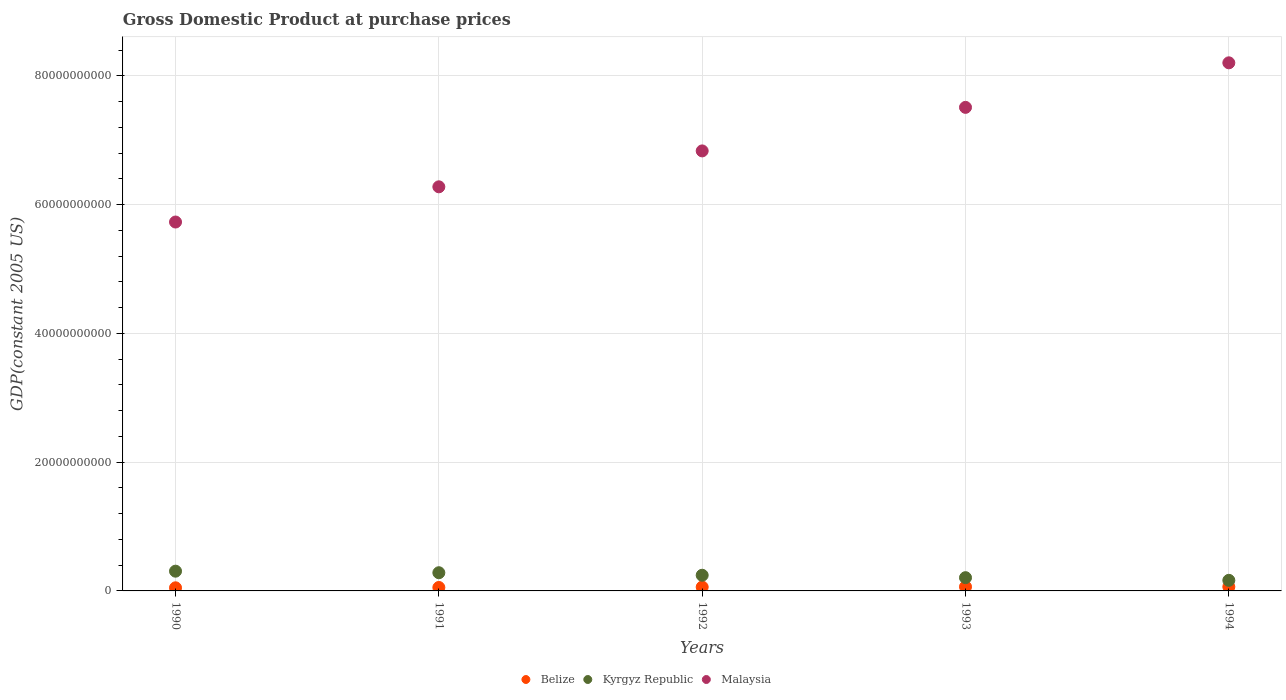What is the GDP at purchase prices in Belize in 1992?
Give a very brief answer. 5.99e+08. Across all years, what is the maximum GDP at purchase prices in Malaysia?
Your answer should be very brief. 8.20e+1. Across all years, what is the minimum GDP at purchase prices in Kyrgyz Republic?
Your response must be concise. 1.64e+09. In which year was the GDP at purchase prices in Kyrgyz Republic maximum?
Give a very brief answer. 1990. In which year was the GDP at purchase prices in Kyrgyz Republic minimum?
Your answer should be very brief. 1994. What is the total GDP at purchase prices in Malaysia in the graph?
Give a very brief answer. 3.46e+11. What is the difference between the GDP at purchase prices in Kyrgyz Republic in 1990 and that in 1991?
Offer a very short reply. 2.41e+08. What is the difference between the GDP at purchase prices in Belize in 1993 and the GDP at purchase prices in Malaysia in 1991?
Provide a succinct answer. -6.21e+1. What is the average GDP at purchase prices in Kyrgyz Republic per year?
Provide a succinct answer. 2.41e+09. In the year 1993, what is the difference between the GDP at purchase prices in Belize and GDP at purchase prices in Kyrgyz Republic?
Offer a terse response. -1.42e+09. In how many years, is the GDP at purchase prices in Belize greater than 24000000000 US$?
Offer a terse response. 0. What is the ratio of the GDP at purchase prices in Kyrgyz Republic in 1990 to that in 1992?
Provide a succinct answer. 1.26. Is the GDP at purchase prices in Kyrgyz Republic in 1992 less than that in 1993?
Give a very brief answer. No. Is the difference between the GDP at purchase prices in Belize in 1990 and 1994 greater than the difference between the GDP at purchase prices in Kyrgyz Republic in 1990 and 1994?
Provide a succinct answer. No. What is the difference between the highest and the second highest GDP at purchase prices in Kyrgyz Republic?
Keep it short and to the point. 2.41e+08. What is the difference between the highest and the lowest GDP at purchase prices in Kyrgyz Republic?
Give a very brief answer. 1.42e+09. Is the sum of the GDP at purchase prices in Malaysia in 1990 and 1991 greater than the maximum GDP at purchase prices in Belize across all years?
Your answer should be very brief. Yes. Is it the case that in every year, the sum of the GDP at purchase prices in Belize and GDP at purchase prices in Kyrgyz Republic  is greater than the GDP at purchase prices in Malaysia?
Offer a terse response. No. Does the GDP at purchase prices in Kyrgyz Republic monotonically increase over the years?
Your answer should be compact. No. What is the difference between two consecutive major ticks on the Y-axis?
Ensure brevity in your answer.  2.00e+1. Are the values on the major ticks of Y-axis written in scientific E-notation?
Ensure brevity in your answer.  No. Does the graph contain any zero values?
Ensure brevity in your answer.  No. Does the graph contain grids?
Make the answer very short. Yes. Where does the legend appear in the graph?
Your answer should be very brief. Bottom center. How are the legend labels stacked?
Your response must be concise. Horizontal. What is the title of the graph?
Give a very brief answer. Gross Domestic Product at purchase prices. Does "Montenegro" appear as one of the legend labels in the graph?
Provide a succinct answer. No. What is the label or title of the Y-axis?
Keep it short and to the point. GDP(constant 2005 US). What is the GDP(constant 2005 US) in Belize in 1990?
Your answer should be very brief. 4.84e+08. What is the GDP(constant 2005 US) in Kyrgyz Republic in 1990?
Your answer should be compact. 3.07e+09. What is the GDP(constant 2005 US) of Malaysia in 1990?
Make the answer very short. 5.73e+1. What is the GDP(constant 2005 US) of Belize in 1991?
Ensure brevity in your answer.  5.35e+08. What is the GDP(constant 2005 US) in Kyrgyz Republic in 1991?
Make the answer very short. 2.83e+09. What is the GDP(constant 2005 US) of Malaysia in 1991?
Provide a short and direct response. 6.28e+1. What is the GDP(constant 2005 US) of Belize in 1992?
Offer a very short reply. 5.99e+08. What is the GDP(constant 2005 US) of Kyrgyz Republic in 1992?
Provide a short and direct response. 2.43e+09. What is the GDP(constant 2005 US) of Malaysia in 1992?
Keep it short and to the point. 6.84e+1. What is the GDP(constant 2005 US) of Belize in 1993?
Make the answer very short. 6.37e+08. What is the GDP(constant 2005 US) of Kyrgyz Republic in 1993?
Your answer should be compact. 2.06e+09. What is the GDP(constant 2005 US) in Malaysia in 1993?
Make the answer very short. 7.51e+1. What is the GDP(constant 2005 US) of Belize in 1994?
Provide a succinct answer. 6.38e+08. What is the GDP(constant 2005 US) of Kyrgyz Republic in 1994?
Make the answer very short. 1.64e+09. What is the GDP(constant 2005 US) in Malaysia in 1994?
Ensure brevity in your answer.  8.20e+1. Across all years, what is the maximum GDP(constant 2005 US) in Belize?
Your response must be concise. 6.38e+08. Across all years, what is the maximum GDP(constant 2005 US) in Kyrgyz Republic?
Provide a succinct answer. 3.07e+09. Across all years, what is the maximum GDP(constant 2005 US) of Malaysia?
Your response must be concise. 8.20e+1. Across all years, what is the minimum GDP(constant 2005 US) of Belize?
Offer a terse response. 4.84e+08. Across all years, what is the minimum GDP(constant 2005 US) of Kyrgyz Republic?
Your answer should be very brief. 1.64e+09. Across all years, what is the minimum GDP(constant 2005 US) of Malaysia?
Make the answer very short. 5.73e+1. What is the total GDP(constant 2005 US) of Belize in the graph?
Offer a terse response. 2.89e+09. What is the total GDP(constant 2005 US) of Kyrgyz Republic in the graph?
Keep it short and to the point. 1.20e+1. What is the total GDP(constant 2005 US) of Malaysia in the graph?
Give a very brief answer. 3.46e+11. What is the difference between the GDP(constant 2005 US) in Belize in 1990 and that in 1991?
Give a very brief answer. -5.08e+07. What is the difference between the GDP(constant 2005 US) of Kyrgyz Republic in 1990 and that in 1991?
Your response must be concise. 2.41e+08. What is the difference between the GDP(constant 2005 US) in Malaysia in 1990 and that in 1991?
Your answer should be very brief. -5.47e+09. What is the difference between the GDP(constant 2005 US) of Belize in 1990 and that in 1992?
Offer a very short reply. -1.15e+08. What is the difference between the GDP(constant 2005 US) of Kyrgyz Republic in 1990 and that in 1992?
Your answer should be very brief. 6.33e+08. What is the difference between the GDP(constant 2005 US) in Malaysia in 1990 and that in 1992?
Keep it short and to the point. -1.10e+1. What is the difference between the GDP(constant 2005 US) in Belize in 1990 and that in 1993?
Keep it short and to the point. -1.53e+08. What is the difference between the GDP(constant 2005 US) of Kyrgyz Republic in 1990 and that in 1993?
Your response must be concise. 1.01e+09. What is the difference between the GDP(constant 2005 US) of Malaysia in 1990 and that in 1993?
Keep it short and to the point. -1.78e+1. What is the difference between the GDP(constant 2005 US) in Belize in 1990 and that in 1994?
Your answer should be compact. -1.54e+08. What is the difference between the GDP(constant 2005 US) of Kyrgyz Republic in 1990 and that in 1994?
Offer a very short reply. 1.42e+09. What is the difference between the GDP(constant 2005 US) of Malaysia in 1990 and that in 1994?
Give a very brief answer. -2.47e+1. What is the difference between the GDP(constant 2005 US) in Belize in 1991 and that in 1992?
Your answer should be compact. -6.44e+07. What is the difference between the GDP(constant 2005 US) of Kyrgyz Republic in 1991 and that in 1992?
Provide a short and direct response. 3.93e+08. What is the difference between the GDP(constant 2005 US) in Malaysia in 1991 and that in 1992?
Provide a succinct answer. -5.58e+09. What is the difference between the GDP(constant 2005 US) in Belize in 1991 and that in 1993?
Offer a terse response. -1.02e+08. What is the difference between the GDP(constant 2005 US) in Kyrgyz Republic in 1991 and that in 1993?
Your response must be concise. 7.69e+08. What is the difference between the GDP(constant 2005 US) of Malaysia in 1991 and that in 1993?
Offer a very short reply. -1.23e+1. What is the difference between the GDP(constant 2005 US) of Belize in 1991 and that in 1994?
Ensure brevity in your answer.  -1.03e+08. What is the difference between the GDP(constant 2005 US) of Kyrgyz Republic in 1991 and that in 1994?
Offer a very short reply. 1.18e+09. What is the difference between the GDP(constant 2005 US) of Malaysia in 1991 and that in 1994?
Your response must be concise. -1.93e+1. What is the difference between the GDP(constant 2005 US) of Belize in 1992 and that in 1993?
Your response must be concise. -3.76e+07. What is the difference between the GDP(constant 2005 US) in Kyrgyz Republic in 1992 and that in 1993?
Provide a succinct answer. 3.76e+08. What is the difference between the GDP(constant 2005 US) in Malaysia in 1992 and that in 1993?
Offer a very short reply. -6.76e+09. What is the difference between the GDP(constant 2005 US) in Belize in 1992 and that in 1994?
Ensure brevity in your answer.  -3.86e+07. What is the difference between the GDP(constant 2005 US) in Kyrgyz Republic in 1992 and that in 1994?
Provide a short and direct response. 7.90e+08. What is the difference between the GDP(constant 2005 US) in Malaysia in 1992 and that in 1994?
Ensure brevity in your answer.  -1.37e+1. What is the difference between the GDP(constant 2005 US) in Belize in 1993 and that in 1994?
Your answer should be compact. -1.01e+06. What is the difference between the GDP(constant 2005 US) of Kyrgyz Republic in 1993 and that in 1994?
Make the answer very short. 4.13e+08. What is the difference between the GDP(constant 2005 US) in Malaysia in 1993 and that in 1994?
Make the answer very short. -6.92e+09. What is the difference between the GDP(constant 2005 US) of Belize in 1990 and the GDP(constant 2005 US) of Kyrgyz Republic in 1991?
Offer a terse response. -2.34e+09. What is the difference between the GDP(constant 2005 US) in Belize in 1990 and the GDP(constant 2005 US) in Malaysia in 1991?
Provide a succinct answer. -6.23e+1. What is the difference between the GDP(constant 2005 US) of Kyrgyz Republic in 1990 and the GDP(constant 2005 US) of Malaysia in 1991?
Provide a short and direct response. -5.97e+1. What is the difference between the GDP(constant 2005 US) of Belize in 1990 and the GDP(constant 2005 US) of Kyrgyz Republic in 1992?
Your answer should be compact. -1.95e+09. What is the difference between the GDP(constant 2005 US) in Belize in 1990 and the GDP(constant 2005 US) in Malaysia in 1992?
Provide a succinct answer. -6.79e+1. What is the difference between the GDP(constant 2005 US) in Kyrgyz Republic in 1990 and the GDP(constant 2005 US) in Malaysia in 1992?
Your response must be concise. -6.53e+1. What is the difference between the GDP(constant 2005 US) of Belize in 1990 and the GDP(constant 2005 US) of Kyrgyz Republic in 1993?
Offer a very short reply. -1.57e+09. What is the difference between the GDP(constant 2005 US) of Belize in 1990 and the GDP(constant 2005 US) of Malaysia in 1993?
Keep it short and to the point. -7.46e+1. What is the difference between the GDP(constant 2005 US) of Kyrgyz Republic in 1990 and the GDP(constant 2005 US) of Malaysia in 1993?
Offer a very short reply. -7.21e+1. What is the difference between the GDP(constant 2005 US) in Belize in 1990 and the GDP(constant 2005 US) in Kyrgyz Republic in 1994?
Offer a terse response. -1.16e+09. What is the difference between the GDP(constant 2005 US) in Belize in 1990 and the GDP(constant 2005 US) in Malaysia in 1994?
Your answer should be compact. -8.16e+1. What is the difference between the GDP(constant 2005 US) of Kyrgyz Republic in 1990 and the GDP(constant 2005 US) of Malaysia in 1994?
Offer a very short reply. -7.90e+1. What is the difference between the GDP(constant 2005 US) of Belize in 1991 and the GDP(constant 2005 US) of Kyrgyz Republic in 1992?
Your answer should be compact. -1.90e+09. What is the difference between the GDP(constant 2005 US) in Belize in 1991 and the GDP(constant 2005 US) in Malaysia in 1992?
Ensure brevity in your answer.  -6.78e+1. What is the difference between the GDP(constant 2005 US) in Kyrgyz Republic in 1991 and the GDP(constant 2005 US) in Malaysia in 1992?
Ensure brevity in your answer.  -6.55e+1. What is the difference between the GDP(constant 2005 US) of Belize in 1991 and the GDP(constant 2005 US) of Kyrgyz Republic in 1993?
Make the answer very short. -1.52e+09. What is the difference between the GDP(constant 2005 US) in Belize in 1991 and the GDP(constant 2005 US) in Malaysia in 1993?
Ensure brevity in your answer.  -7.46e+1. What is the difference between the GDP(constant 2005 US) of Kyrgyz Republic in 1991 and the GDP(constant 2005 US) of Malaysia in 1993?
Make the answer very short. -7.23e+1. What is the difference between the GDP(constant 2005 US) of Belize in 1991 and the GDP(constant 2005 US) of Kyrgyz Republic in 1994?
Make the answer very short. -1.11e+09. What is the difference between the GDP(constant 2005 US) in Belize in 1991 and the GDP(constant 2005 US) in Malaysia in 1994?
Offer a terse response. -8.15e+1. What is the difference between the GDP(constant 2005 US) in Kyrgyz Republic in 1991 and the GDP(constant 2005 US) in Malaysia in 1994?
Provide a short and direct response. -7.92e+1. What is the difference between the GDP(constant 2005 US) of Belize in 1992 and the GDP(constant 2005 US) of Kyrgyz Republic in 1993?
Provide a short and direct response. -1.46e+09. What is the difference between the GDP(constant 2005 US) in Belize in 1992 and the GDP(constant 2005 US) in Malaysia in 1993?
Your response must be concise. -7.45e+1. What is the difference between the GDP(constant 2005 US) in Kyrgyz Republic in 1992 and the GDP(constant 2005 US) in Malaysia in 1993?
Your response must be concise. -7.27e+1. What is the difference between the GDP(constant 2005 US) of Belize in 1992 and the GDP(constant 2005 US) of Kyrgyz Republic in 1994?
Provide a short and direct response. -1.05e+09. What is the difference between the GDP(constant 2005 US) of Belize in 1992 and the GDP(constant 2005 US) of Malaysia in 1994?
Keep it short and to the point. -8.14e+1. What is the difference between the GDP(constant 2005 US) in Kyrgyz Republic in 1992 and the GDP(constant 2005 US) in Malaysia in 1994?
Your answer should be very brief. -7.96e+1. What is the difference between the GDP(constant 2005 US) in Belize in 1993 and the GDP(constant 2005 US) in Kyrgyz Republic in 1994?
Ensure brevity in your answer.  -1.01e+09. What is the difference between the GDP(constant 2005 US) of Belize in 1993 and the GDP(constant 2005 US) of Malaysia in 1994?
Your answer should be compact. -8.14e+1. What is the difference between the GDP(constant 2005 US) of Kyrgyz Republic in 1993 and the GDP(constant 2005 US) of Malaysia in 1994?
Give a very brief answer. -8.00e+1. What is the average GDP(constant 2005 US) in Belize per year?
Give a very brief answer. 5.79e+08. What is the average GDP(constant 2005 US) in Kyrgyz Republic per year?
Give a very brief answer. 2.41e+09. What is the average GDP(constant 2005 US) of Malaysia per year?
Provide a succinct answer. 6.91e+1. In the year 1990, what is the difference between the GDP(constant 2005 US) of Belize and GDP(constant 2005 US) of Kyrgyz Republic?
Your answer should be very brief. -2.58e+09. In the year 1990, what is the difference between the GDP(constant 2005 US) in Belize and GDP(constant 2005 US) in Malaysia?
Your answer should be very brief. -5.68e+1. In the year 1990, what is the difference between the GDP(constant 2005 US) of Kyrgyz Republic and GDP(constant 2005 US) of Malaysia?
Give a very brief answer. -5.42e+1. In the year 1991, what is the difference between the GDP(constant 2005 US) in Belize and GDP(constant 2005 US) in Kyrgyz Republic?
Your answer should be compact. -2.29e+09. In the year 1991, what is the difference between the GDP(constant 2005 US) of Belize and GDP(constant 2005 US) of Malaysia?
Offer a very short reply. -6.22e+1. In the year 1991, what is the difference between the GDP(constant 2005 US) of Kyrgyz Republic and GDP(constant 2005 US) of Malaysia?
Your answer should be compact. -6.00e+1. In the year 1992, what is the difference between the GDP(constant 2005 US) in Belize and GDP(constant 2005 US) in Kyrgyz Republic?
Give a very brief answer. -1.84e+09. In the year 1992, what is the difference between the GDP(constant 2005 US) in Belize and GDP(constant 2005 US) in Malaysia?
Ensure brevity in your answer.  -6.78e+1. In the year 1992, what is the difference between the GDP(constant 2005 US) of Kyrgyz Republic and GDP(constant 2005 US) of Malaysia?
Give a very brief answer. -6.59e+1. In the year 1993, what is the difference between the GDP(constant 2005 US) of Belize and GDP(constant 2005 US) of Kyrgyz Republic?
Provide a succinct answer. -1.42e+09. In the year 1993, what is the difference between the GDP(constant 2005 US) of Belize and GDP(constant 2005 US) of Malaysia?
Give a very brief answer. -7.45e+1. In the year 1993, what is the difference between the GDP(constant 2005 US) of Kyrgyz Republic and GDP(constant 2005 US) of Malaysia?
Give a very brief answer. -7.31e+1. In the year 1994, what is the difference between the GDP(constant 2005 US) in Belize and GDP(constant 2005 US) in Kyrgyz Republic?
Provide a short and direct response. -1.01e+09. In the year 1994, what is the difference between the GDP(constant 2005 US) in Belize and GDP(constant 2005 US) in Malaysia?
Provide a succinct answer. -8.14e+1. In the year 1994, what is the difference between the GDP(constant 2005 US) in Kyrgyz Republic and GDP(constant 2005 US) in Malaysia?
Your response must be concise. -8.04e+1. What is the ratio of the GDP(constant 2005 US) of Belize in 1990 to that in 1991?
Provide a succinct answer. 0.91. What is the ratio of the GDP(constant 2005 US) of Kyrgyz Republic in 1990 to that in 1991?
Make the answer very short. 1.09. What is the ratio of the GDP(constant 2005 US) of Malaysia in 1990 to that in 1991?
Ensure brevity in your answer.  0.91. What is the ratio of the GDP(constant 2005 US) in Belize in 1990 to that in 1992?
Offer a terse response. 0.81. What is the ratio of the GDP(constant 2005 US) in Kyrgyz Republic in 1990 to that in 1992?
Ensure brevity in your answer.  1.26. What is the ratio of the GDP(constant 2005 US) of Malaysia in 1990 to that in 1992?
Offer a very short reply. 0.84. What is the ratio of the GDP(constant 2005 US) in Belize in 1990 to that in 1993?
Your answer should be very brief. 0.76. What is the ratio of the GDP(constant 2005 US) in Kyrgyz Republic in 1990 to that in 1993?
Offer a very short reply. 1.49. What is the ratio of the GDP(constant 2005 US) in Malaysia in 1990 to that in 1993?
Keep it short and to the point. 0.76. What is the ratio of the GDP(constant 2005 US) of Belize in 1990 to that in 1994?
Give a very brief answer. 0.76. What is the ratio of the GDP(constant 2005 US) in Kyrgyz Republic in 1990 to that in 1994?
Offer a terse response. 1.87. What is the ratio of the GDP(constant 2005 US) of Malaysia in 1990 to that in 1994?
Your response must be concise. 0.7. What is the ratio of the GDP(constant 2005 US) in Belize in 1991 to that in 1992?
Offer a terse response. 0.89. What is the ratio of the GDP(constant 2005 US) in Kyrgyz Republic in 1991 to that in 1992?
Offer a terse response. 1.16. What is the ratio of the GDP(constant 2005 US) of Malaysia in 1991 to that in 1992?
Ensure brevity in your answer.  0.92. What is the ratio of the GDP(constant 2005 US) in Belize in 1991 to that in 1993?
Your response must be concise. 0.84. What is the ratio of the GDP(constant 2005 US) of Kyrgyz Republic in 1991 to that in 1993?
Your response must be concise. 1.37. What is the ratio of the GDP(constant 2005 US) of Malaysia in 1991 to that in 1993?
Your answer should be compact. 0.84. What is the ratio of the GDP(constant 2005 US) of Belize in 1991 to that in 1994?
Provide a short and direct response. 0.84. What is the ratio of the GDP(constant 2005 US) of Kyrgyz Republic in 1991 to that in 1994?
Your response must be concise. 1.72. What is the ratio of the GDP(constant 2005 US) of Malaysia in 1991 to that in 1994?
Give a very brief answer. 0.77. What is the ratio of the GDP(constant 2005 US) in Belize in 1992 to that in 1993?
Your answer should be compact. 0.94. What is the ratio of the GDP(constant 2005 US) in Kyrgyz Republic in 1992 to that in 1993?
Offer a terse response. 1.18. What is the ratio of the GDP(constant 2005 US) in Malaysia in 1992 to that in 1993?
Your answer should be compact. 0.91. What is the ratio of the GDP(constant 2005 US) of Belize in 1992 to that in 1994?
Your answer should be compact. 0.94. What is the ratio of the GDP(constant 2005 US) in Kyrgyz Republic in 1992 to that in 1994?
Give a very brief answer. 1.48. What is the ratio of the GDP(constant 2005 US) of Malaysia in 1992 to that in 1994?
Give a very brief answer. 0.83. What is the ratio of the GDP(constant 2005 US) in Kyrgyz Republic in 1993 to that in 1994?
Offer a terse response. 1.25. What is the ratio of the GDP(constant 2005 US) of Malaysia in 1993 to that in 1994?
Make the answer very short. 0.92. What is the difference between the highest and the second highest GDP(constant 2005 US) in Belize?
Your answer should be compact. 1.01e+06. What is the difference between the highest and the second highest GDP(constant 2005 US) of Kyrgyz Republic?
Offer a very short reply. 2.41e+08. What is the difference between the highest and the second highest GDP(constant 2005 US) in Malaysia?
Your response must be concise. 6.92e+09. What is the difference between the highest and the lowest GDP(constant 2005 US) in Belize?
Offer a very short reply. 1.54e+08. What is the difference between the highest and the lowest GDP(constant 2005 US) in Kyrgyz Republic?
Offer a terse response. 1.42e+09. What is the difference between the highest and the lowest GDP(constant 2005 US) in Malaysia?
Your answer should be compact. 2.47e+1. 